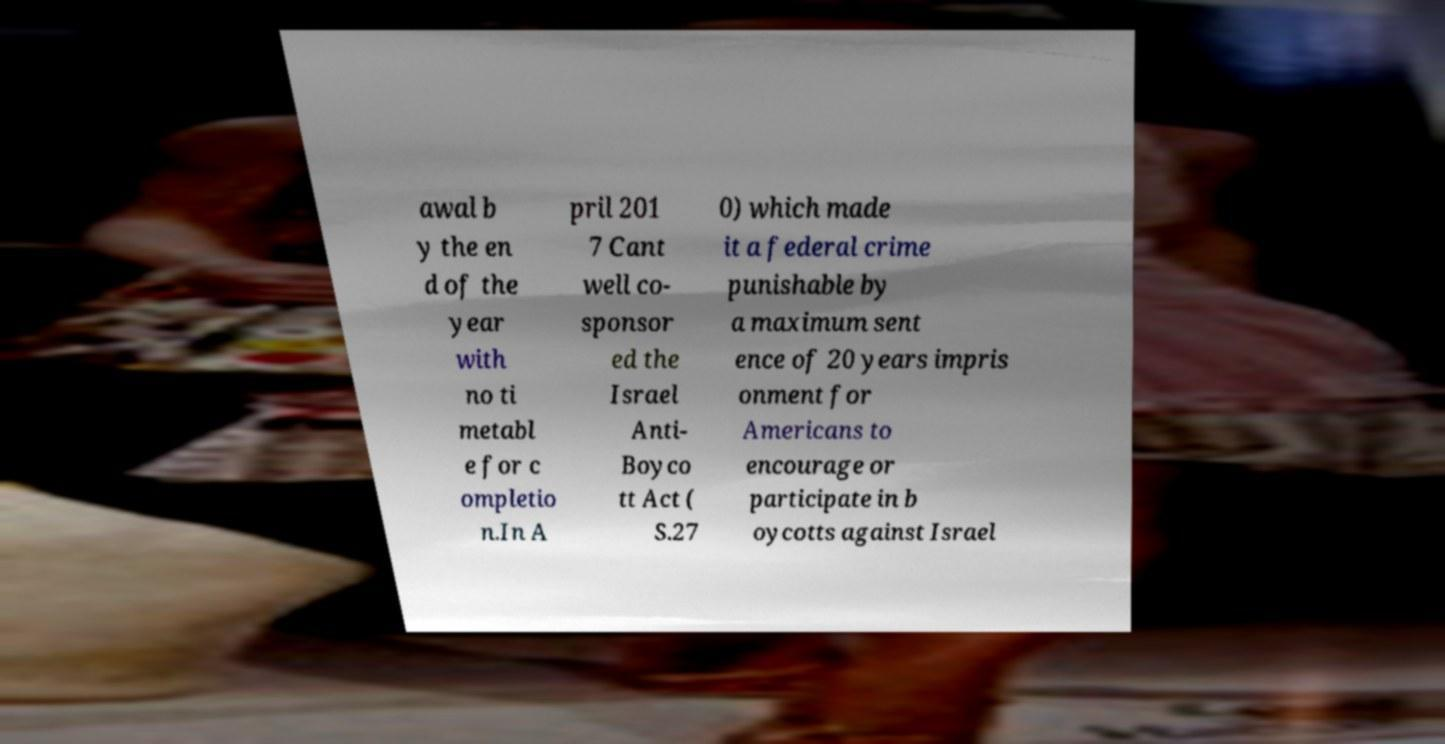Could you assist in decoding the text presented in this image and type it out clearly? awal b y the en d of the year with no ti metabl e for c ompletio n.In A pril 201 7 Cant well co- sponsor ed the Israel Anti- Boyco tt Act ( S.27 0) which made it a federal crime punishable by a maximum sent ence of 20 years impris onment for Americans to encourage or participate in b oycotts against Israel 